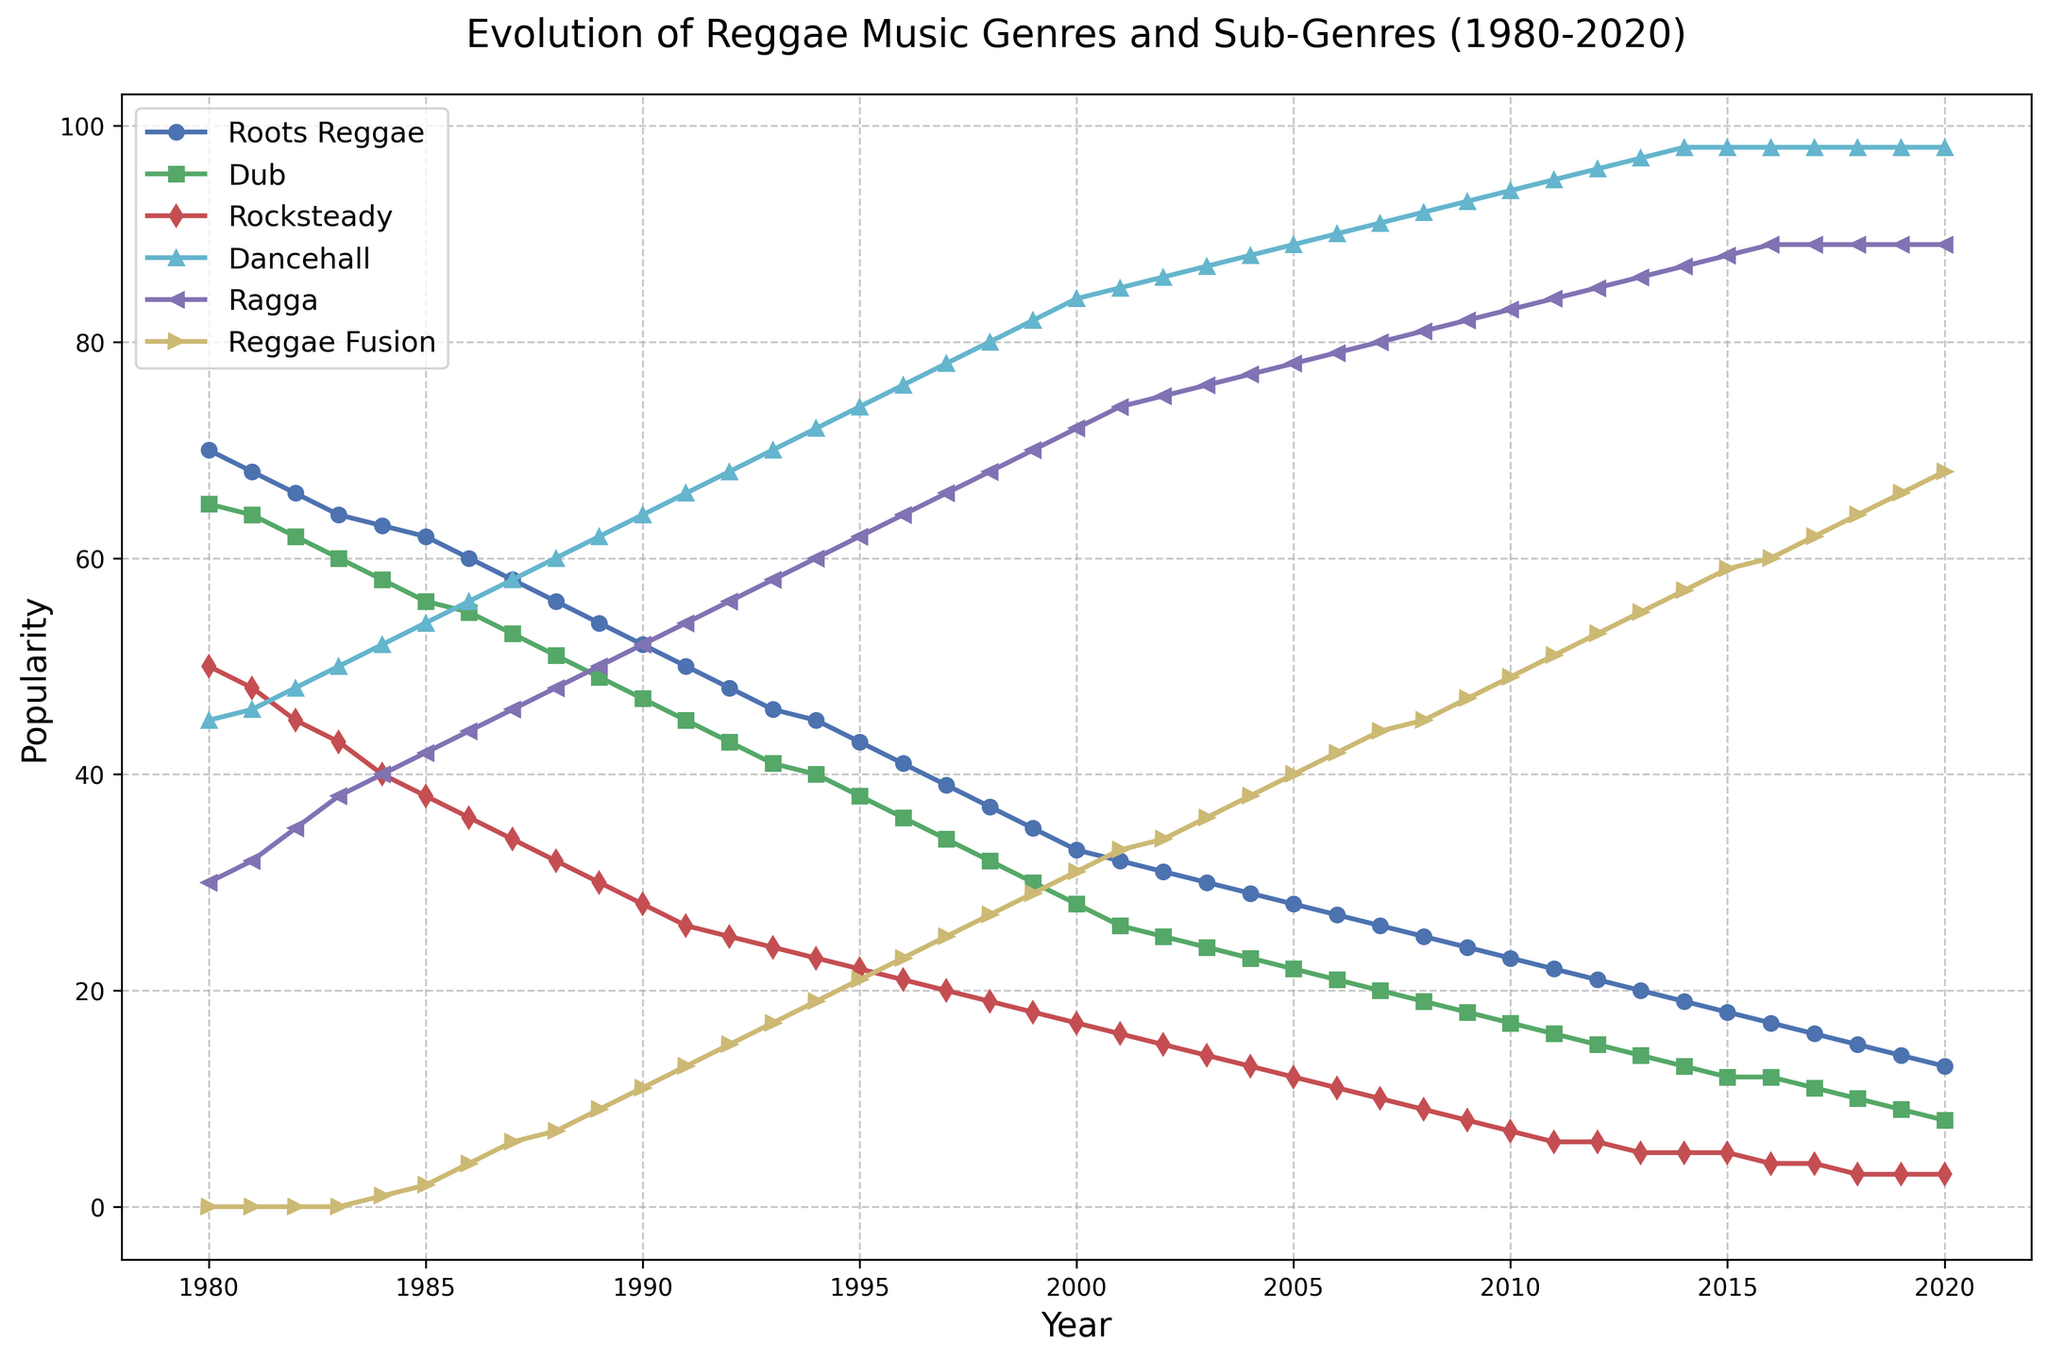what is the most popular genre in 1995? In 1995, observe the lines representing different genres. The line with the highest y-value corresponds to Dancehall.
Answer: Dancehall Which genre saw a continuous rise in its popularity from 1980 to 2020? From the plot, identify the lines that show an increasing trend throughout the entire period. The line for Ragga continuously increases from 1980 to 2020.
Answer: Ragga Between 1980 and 2000, which genre experienced the significant decrease in popularity? Comparing the y-values from 1980 to 2000 for all genres, Roots Reggae shows a significant decline from 70 to 33.
Answer: Roots Reggae By how many points did Dancehall's popularity increase between 1980 and 2010? The popularity of Dancehall in 1980 was 45 and in 2010 it was 94. The increase is calculated as 94 - 45 = 49 points.
Answer: 49 points What is the total popularity of Dub and Rocksteady in 1990? In 1990, the popularity of Dub was 47 and Rocksteady was 28. Summing these values gives us 47 + 28 = 75.
Answer: 75 In which year did Dancehall surpass Roots Reggae in popularity? Find the intersection point of the Dancehall and Roots Reggae lines. Dancehall surpasses Roots Reggae between 1983 and 1984. Thus, 1984 is the first year Dancehall is higher.
Answer: 1984 What is the difference in popularity between Ragga and Reggae Fusion in 2020? In 2020, Ragga's popularity is 89, and Reggae Fusion's is 68. The difference is 89 - 68 = 21.
Answer: 21 What trend do you observe for Rocksteady's popularity over the years? The line for Rocksteady shows a continuous decrease in popularity, starting from 50 in 1980 to 3 in 2020.
Answer: Continuous decrease Was there any genre whose popularity remained constant between two consecutive decades? Observing the data points at decade intervals (1980, 1990, 2000, 2010, 2020), Dancehall remains constant at 98 between 2010 and 2020.
Answer: Yes, Dancehall Which genre shows a significant rise in popularity starting from the late 1990s? Examining the lines, Dancehall shows a sharp increase starting around 1995 and continuing onward.
Answer: Dancehall 